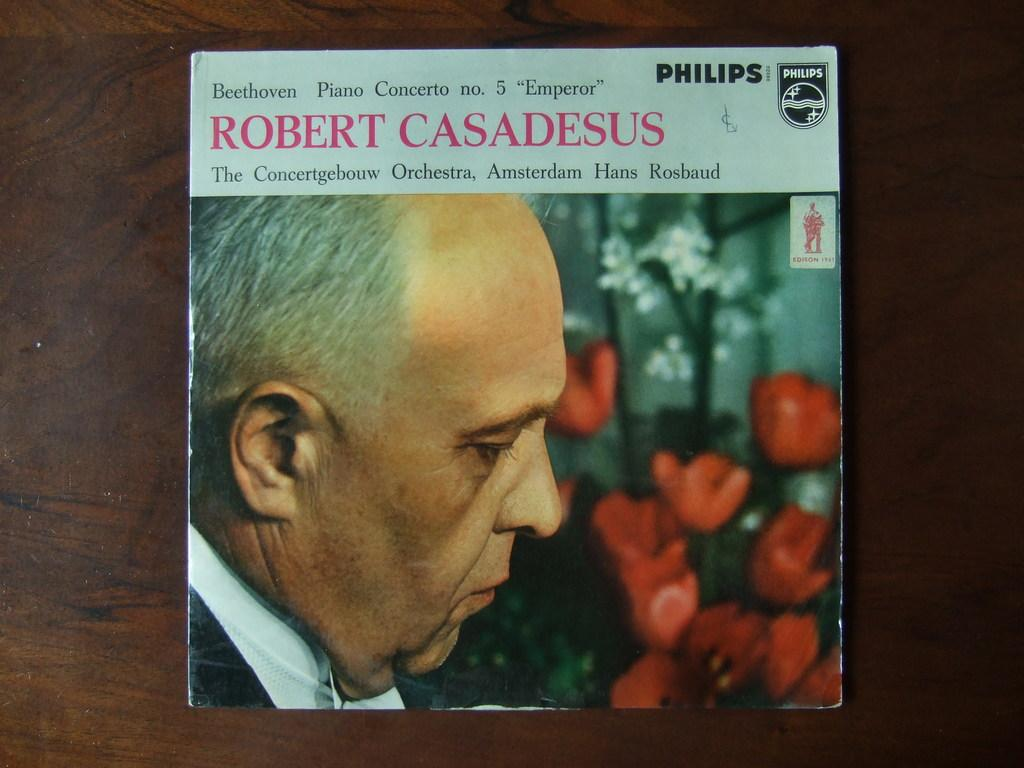What is the main subject of the image? The main subject of the image is the cover page of a book. What type of weather can be seen on the wall in the image? There is no wall or weather depicted in the image; it contains the cover page of a book. 